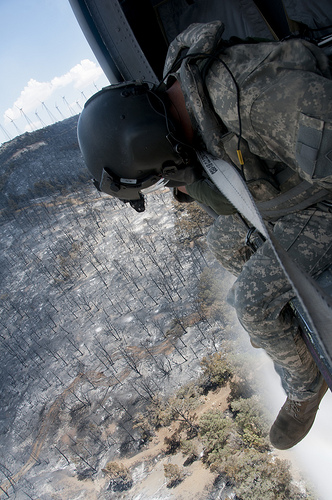<image>
Is the helmet in front of the tree? No. The helmet is not in front of the tree. The spatial positioning shows a different relationship between these objects. Where is the soldier in relation to the forest? Is it above the forest? Yes. The soldier is positioned above the forest in the vertical space, higher up in the scene. 